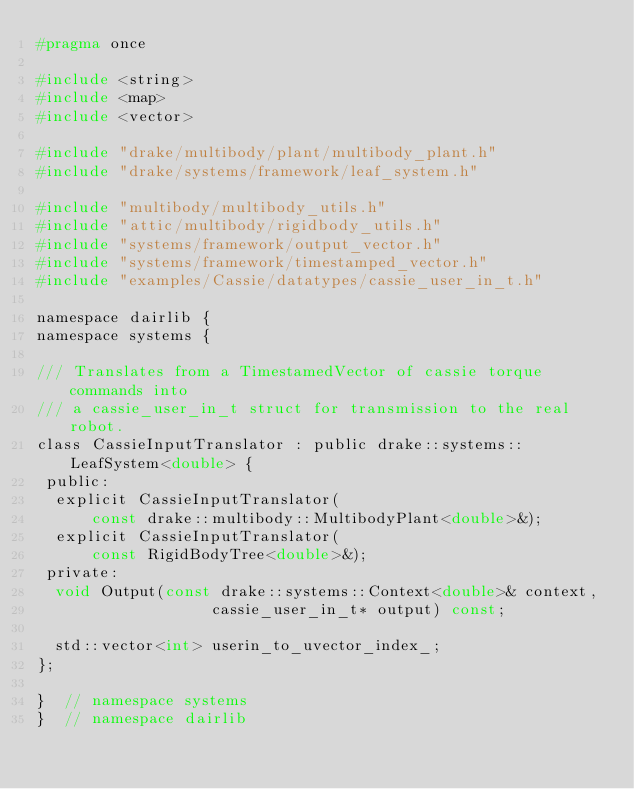Convert code to text. <code><loc_0><loc_0><loc_500><loc_500><_C_>#pragma once

#include <string>
#include <map>
#include <vector>

#include "drake/multibody/plant/multibody_plant.h"
#include "drake/systems/framework/leaf_system.h"

#include "multibody/multibody_utils.h"
#include "attic/multibody/rigidbody_utils.h"
#include "systems/framework/output_vector.h"
#include "systems/framework/timestamped_vector.h"
#include "examples/Cassie/datatypes/cassie_user_in_t.h"

namespace dairlib {
namespace systems {

/// Translates from a TimestamedVector of cassie torque commands into
/// a cassie_user_in_t struct for transmission to the real robot.
class CassieInputTranslator : public drake::systems::LeafSystem<double> {
 public:
  explicit CassieInputTranslator(
      const drake::multibody::MultibodyPlant<double>&);
  explicit CassieInputTranslator(
      const RigidBodyTree<double>&);
 private:
  void Output(const drake::systems::Context<double>& context,
                   cassie_user_in_t* output) const;

  std::vector<int> userin_to_uvector_index_;
};

}  // namespace systems
}  // namespace dairlib
</code> 